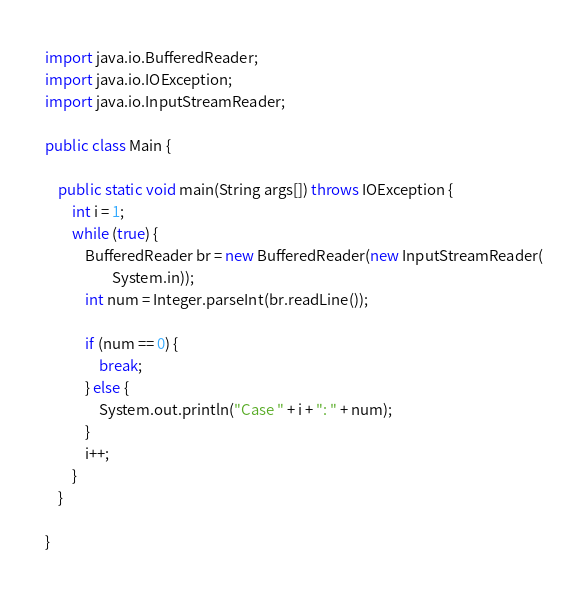Convert code to text. <code><loc_0><loc_0><loc_500><loc_500><_Java_>import java.io.BufferedReader;
import java.io.IOException;
import java.io.InputStreamReader;

public class Main {

	public static void main(String args[]) throws IOException {
		int i = 1;
		while (true) {
			BufferedReader br = new BufferedReader(new InputStreamReader(
					System.in));
			int num = Integer.parseInt(br.readLine());

			if (num == 0) {
				break;
			} else {
				System.out.println("Case " + i + ": " + num);
			}
			i++;
		}
	}

}</code> 